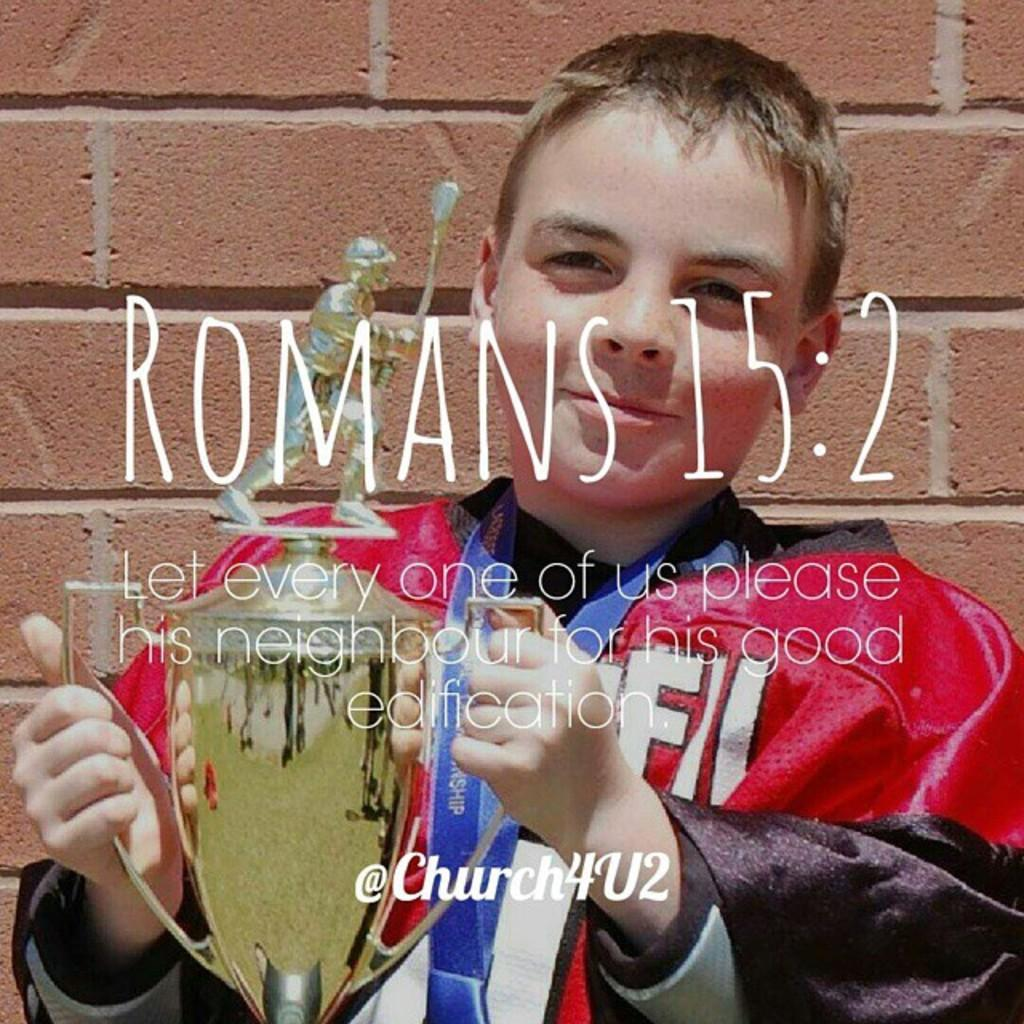Who is the main subject in the image? There is a boy in the image. What is the boy doing in the image? The boy is standing. What is the boy holding in his hand? The boy is holding a memento in his hand. What can be seen in the background of the image? There is a brick wall in the background of the image. Is there any text visible in the image? Yes, there is text visible on the image. What type of lace can be seen on the window in the image? There is no window or lace present in the image. What kind of feast is being prepared in the image? There is no indication of a feast or any food preparation in the image. 